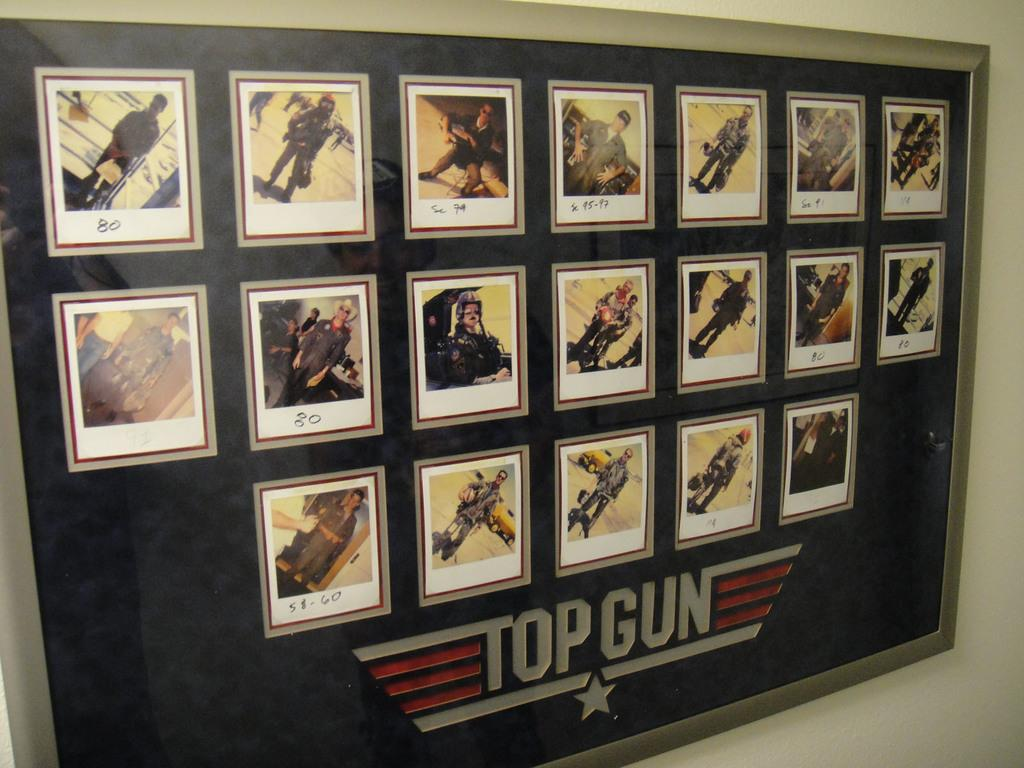Provide a one-sentence caption for the provided image. A framed set of poloroid pictures of airmen with the words Top Gun on it. 